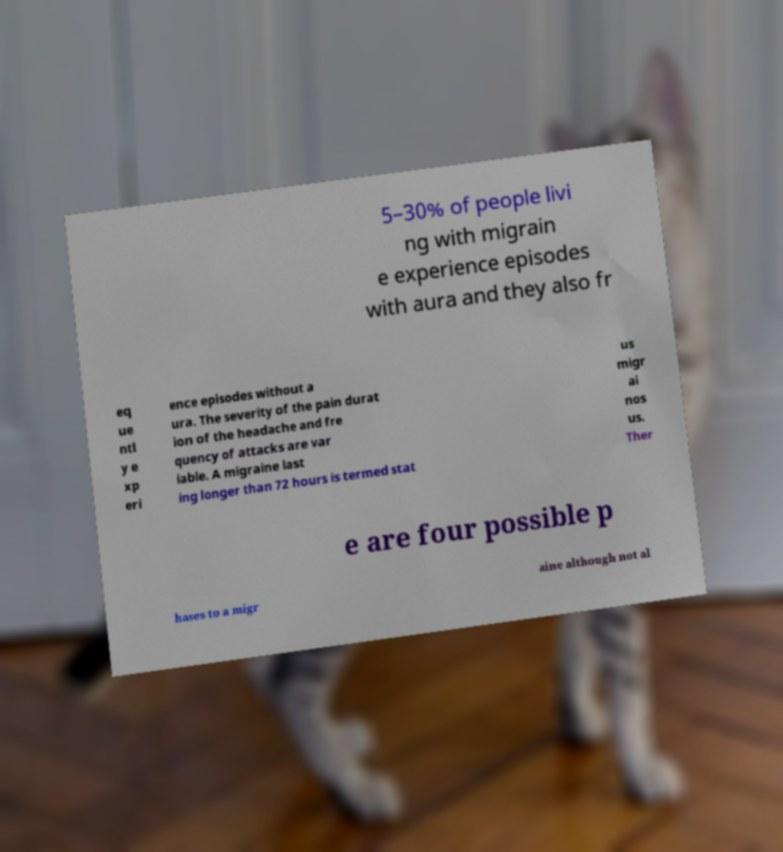Please read and relay the text visible in this image. What does it say? 5–30% of people livi ng with migrain e experience episodes with aura and they also fr eq ue ntl y e xp eri ence episodes without a ura. The severity of the pain durat ion of the headache and fre quency of attacks are var iable. A migraine last ing longer than 72 hours is termed stat us migr ai nos us. Ther e are four possible p hases to a migr aine although not al 